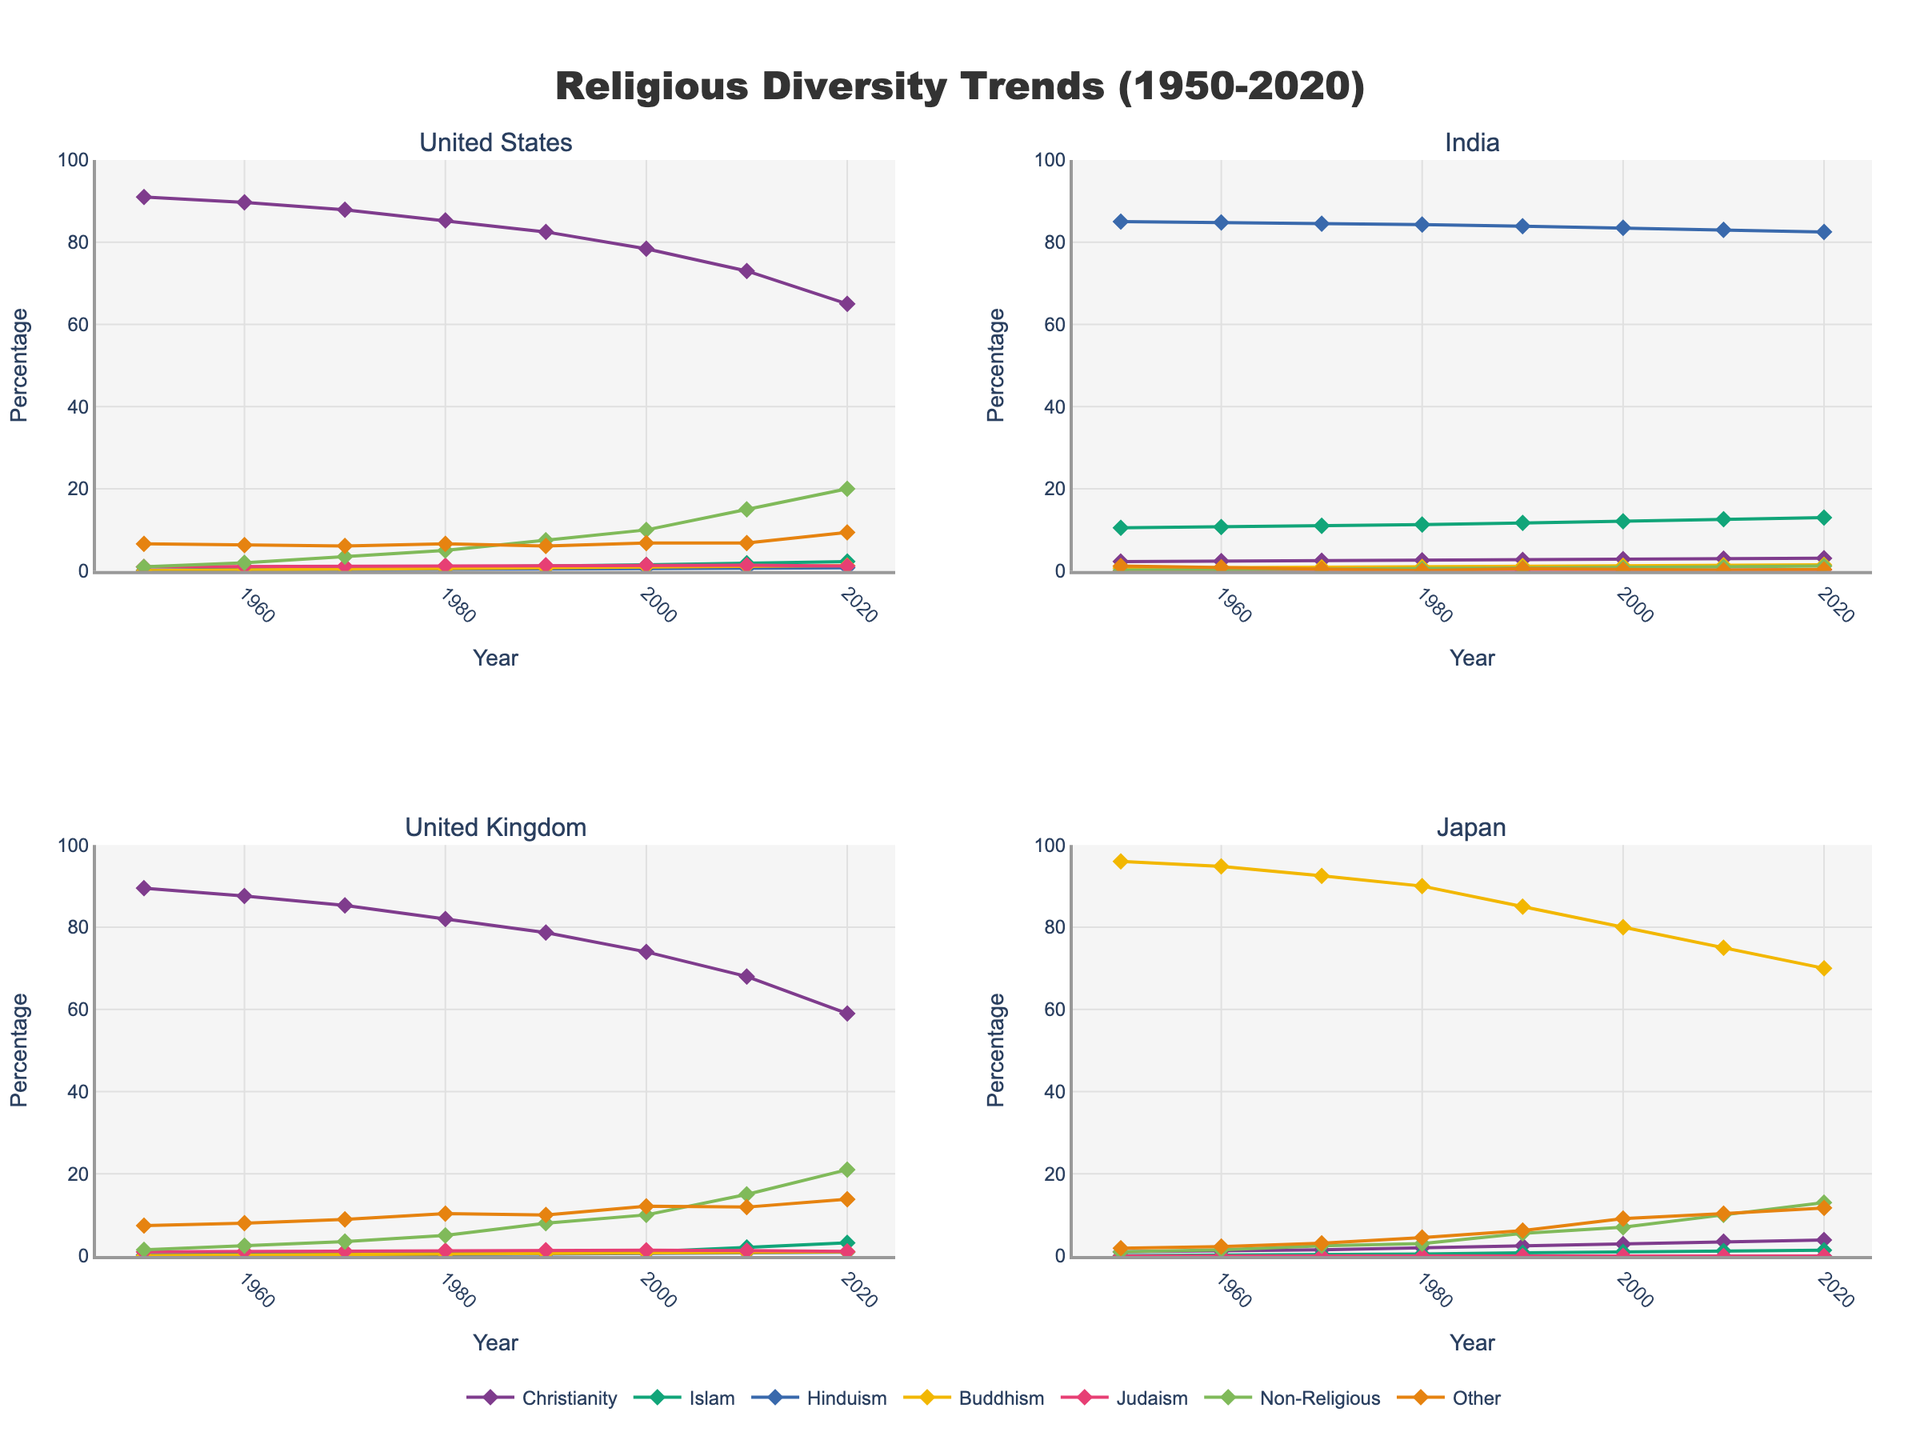What is the title of the figure? The title is usually found at the top center of the plot. In this case, it is clearly labeled as "Religious Diversity Trends (1950-2020)"
Answer: Religious Diversity Trends (1950-2020) Which country shows the highest percentage of non-religious population in 2020? To determine this, look at the end year (2020) for the non-religious trend line in each subplot. Compare the values. The UK shows the highest non-religious percentage at 21%.
Answer: United Kingdom How did the percentage of Christianity in the United States change from 1950 to 2020? Look at the trend line for Christianity in the United States from 1950 to 2020. Note the start value (91.0%) and the end value (65.0%) and compute the difference.
Answer: It decreased by 26% Between 1950 and 2020, which religion in India saw the smallest change in percentage? Check each religion's trend line in India between 1950 and 2020. Compare the start and end values and find the one with the smallest difference. Hinduism starts at 85.0% and ends at 82.5%, showing the smallest change of 2.5%.
Answer: Hinduism In which decade did Japan witness the most significant rise in the percentage of non-religious individuals? Examine the trend line for non-religious people in Japan. Note the increase in percentages in each decade. The most significant rise is between 1980 to 1990, from 3.0% to 5.5%.
Answer: 1980 to 1990 What is the combined percentage of Christianity and Islam in the United Kingdom in 2000? Locate the data points for Christianity (74.0%) and Islam (1.0%) in 2000 in the UK's subplot. Sum these values.
Answer: 75.0% Which country had the highest percentage of Buddhism in 1970? Refer to the Buddhism trend line for all the countries in 1970. Japan had the highest with 92.5%.
Answer: Japan How did the percentage of Judaism in the United States change between 1960 and 1970? Check the Judaism trend line for the United States. Note the values for 1960 (1.1%) and 1970 (1.2%) and calculate the difference.
Answer: It increased by 0.1% Which religious group in India increased the most from 1950 to 2020? By comparing the lines for all religious groups in India, Islam has increased the most from 10.5% to 13.0%, an increment of 2.5%.
Answer: Islam How does the trend of Non-Religious individuals in the United States from 1950 to 2020 compare to that in Japan? Look at the trend lines for Non-Religious in both countries. The US rises steadily from 1.0% to 20.0%, while Japan rises from 1.0% to 13.0%. The US shows a steeper and larger increase.
Answer: The US saw a larger and steeper increase 